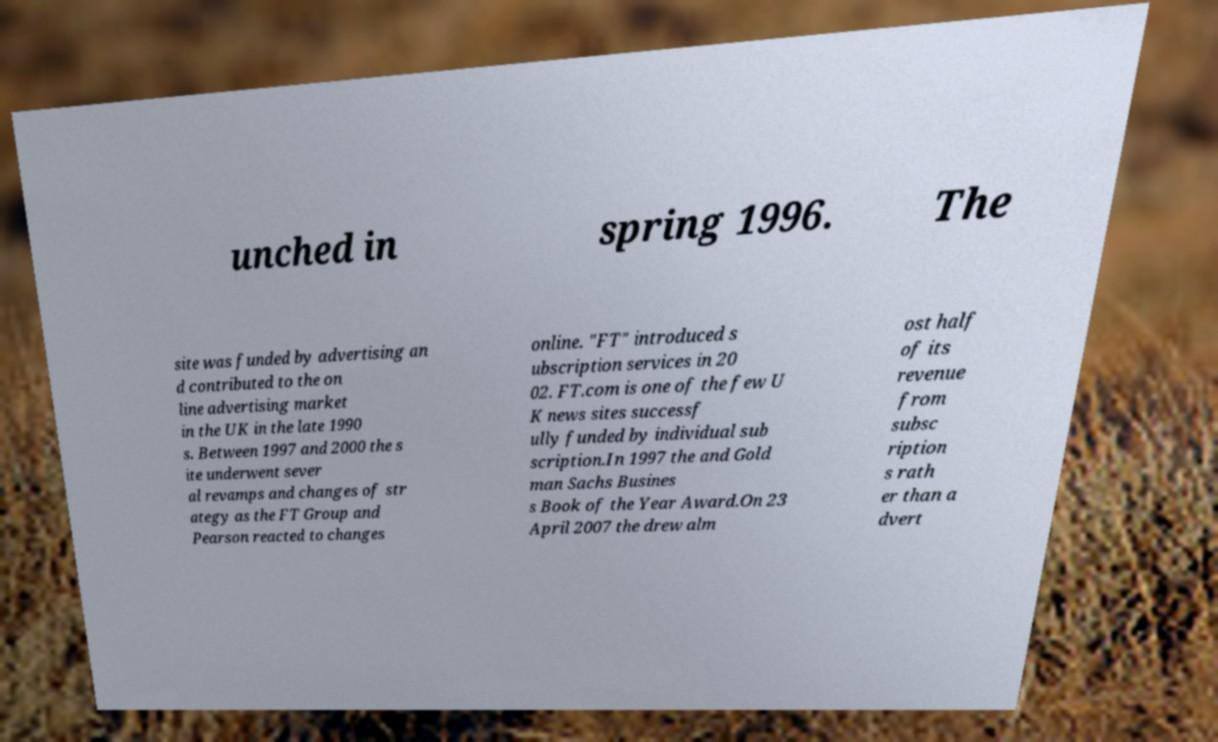Please read and relay the text visible in this image. What does it say? unched in spring 1996. The site was funded by advertising an d contributed to the on line advertising market in the UK in the late 1990 s. Between 1997 and 2000 the s ite underwent sever al revamps and changes of str ategy as the FT Group and Pearson reacted to changes online. "FT" introduced s ubscription services in 20 02. FT.com is one of the few U K news sites successf ully funded by individual sub scription.In 1997 the and Gold man Sachs Busines s Book of the Year Award.On 23 April 2007 the drew alm ost half of its revenue from subsc ription s rath er than a dvert 